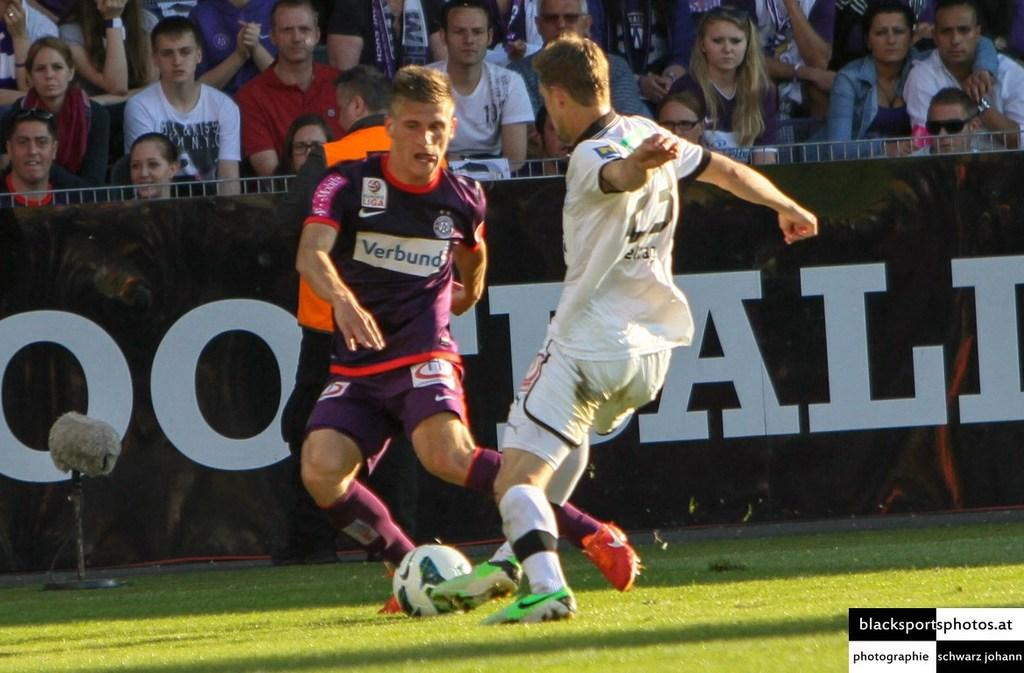What is happening in the background of the image? There is a crowd sitting in the background of the image. What can be seen on the hoarding in the image? The image contains a hoarding, but the content is not specified. What activity are the two men engaged in? The two men are playing football in a playground. Can you see a cat playing with a watch in the image? There is no cat or watch present in the image. Are the parents of the two men playing football in the image? The provided facts do not mention any parents or their involvement in the image. 